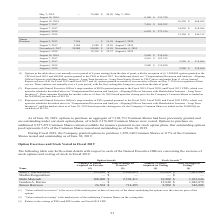According to Opentext Corporation's financial document, What does this table represent? certain details with respect to each of the Named Executive Officers concerning the exercise of stock options and vesting of stock in Fiscal 2019. The document states: "The following table sets forth certain details with respect to each of the Named Executive Officers concerning the exercise of stock options and vesti..." Also, What is  “Value realized on exercise”? the excess of the market price, at date of exercise, of the shares underlying the options over the exercise price of the options. The document states: "(1) “Value realized on exercise” is the excess of the market price, at date of exercise, of the shares underlying the options over the exercise price ..." Also, What is the Number of Shares Acquired on Exercise (#) for Simon Harrison? According to the financial document, 26,504. The relevant text states: "A. Davies — $ — 12,840 $ 1,486,870 Simon Harrison 26,504 $ 714,495 8,980 $ 346,808..." Also, can you calculate: What is the Value Realized on Vesting of Mark J. Barrenechea expressed as a percentage of total Value Realized on Vesting? To answer this question, I need to perform calculations using the financial data. The calculation is: 7,625,905/(7,625,905+1,263,646+1,486,870+346,808), which equals 71.12 (percentage). This is based on the information: "1,486,870 Simon Harrison 26,504 $ 714,495 8,980 $ 346,808 0,900 $ 1,263,646 Gordon A. Davies — $ — 12,840 $ 1,486,870 Simon Harrison 26,504 $ 714,495 8,980 $ 346,808 — — $ — Muhi Majzoub 100,000 $ 2,5..." The key data points involved are: 1,263,646, 1,486,870, 346,808. Also, can you calculate: For Simon Harrison, what is the average value of each share aquired on vesting? Based on the calculation: 346,808/8,980, the result is 38.62. This is based on the information: "2,840 $ 1,486,870 Simon Harrison 26,504 $ 714,495 8,980 $ 346,808 1,486,870 Simon Harrison 26,504 $ 714,495 8,980 $ 346,808..." The key data points involved are: 346,808, 8,980. Also, can you calculate: What is the Total Value Realized on Exercise? Based on the calculation: 2,801,023+2,592,411+714,495, the result is 6107929. This is based on the information: "— $ — 12,840 $ 1,486,870 Simon Harrison 26,504 $ 714,495 8,980 $ 346,808 hu Ranganathan — $ — — $ — Muhi Majzoub 100,000 $ 2,592,411 10,900 $ 1,263,646 Gordon A. Davies — $ — 12,840 $ 1,486,870 Simon ..." The key data points involved are: 2,592,411, 2,801,023, 714,495. 